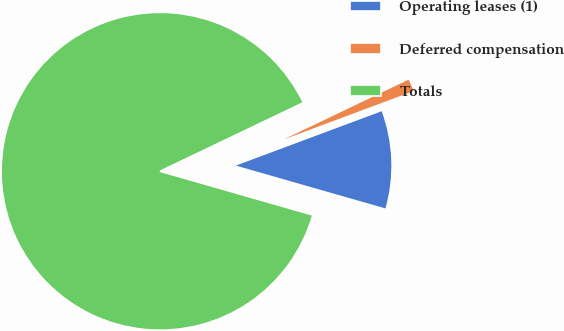Convert chart. <chart><loc_0><loc_0><loc_500><loc_500><pie_chart><fcel>Operating leases (1)<fcel>Deferred compensation<fcel>Totals<nl><fcel>10.12%<fcel>1.42%<fcel>88.45%<nl></chart> 